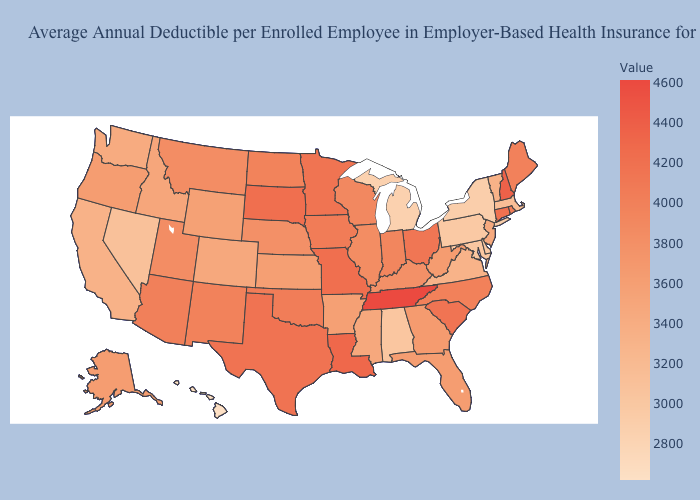Does New York have the lowest value in the Northeast?
Keep it brief. Yes. Which states have the highest value in the USA?
Short answer required. Tennessee. Among the states that border Minnesota , does South Dakota have the highest value?
Keep it brief. Yes. Does Tennessee have the highest value in the USA?
Quick response, please. Yes. Does Hawaii have the lowest value in the West?
Short answer required. Yes. 